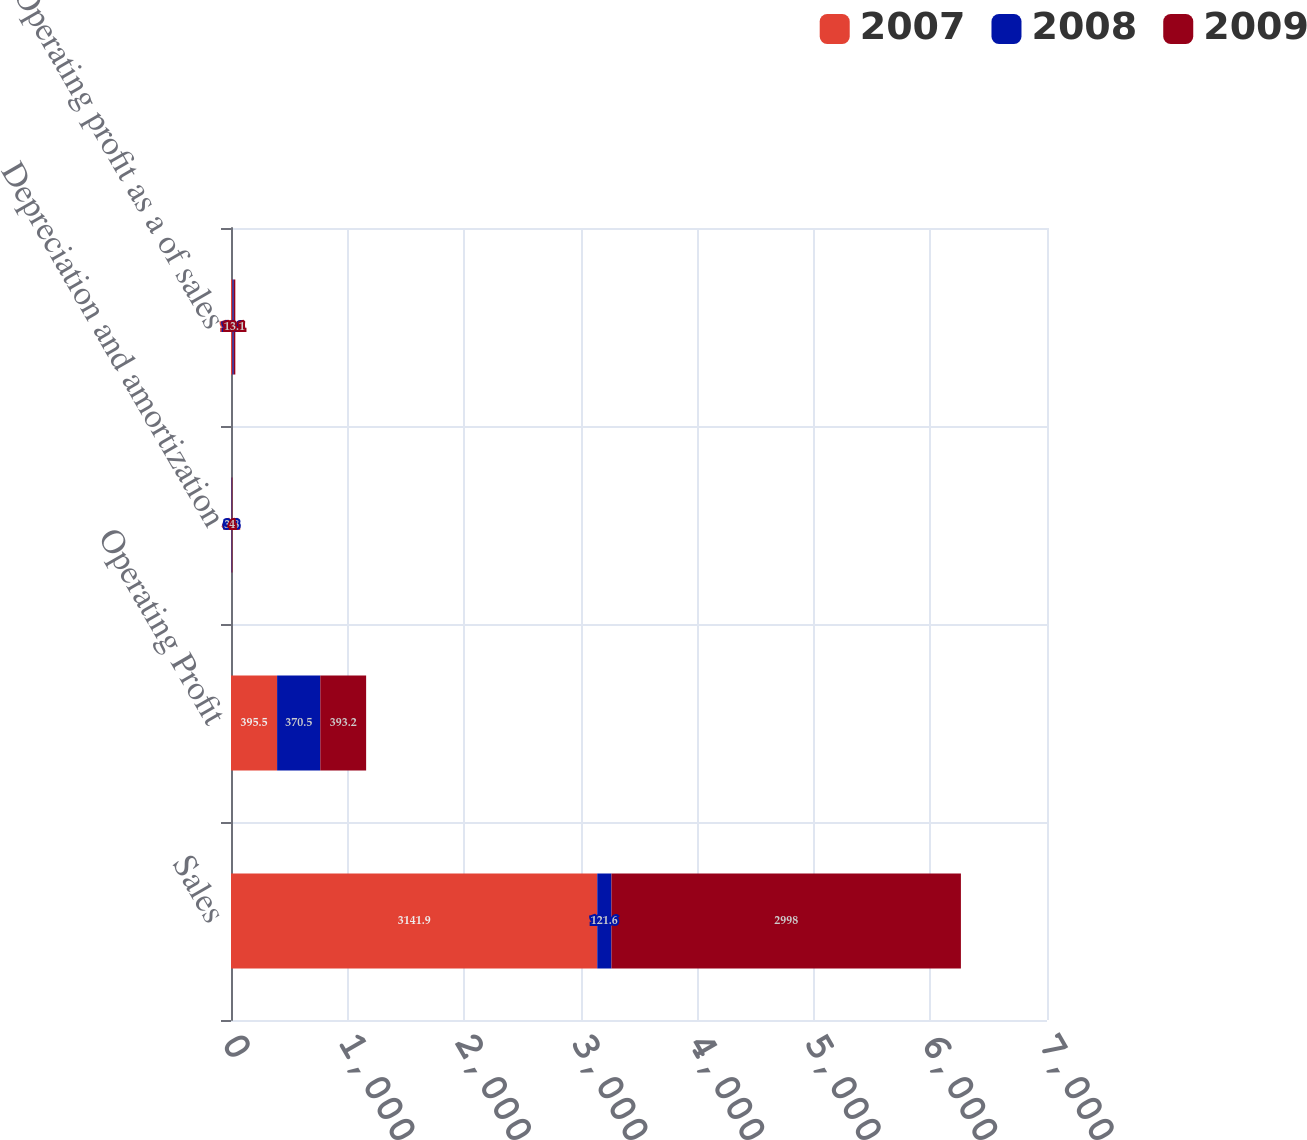Convert chart to OTSL. <chart><loc_0><loc_0><loc_500><loc_500><stacked_bar_chart><ecel><fcel>Sales<fcel>Operating Profit<fcel>Depreciation and amortization<fcel>Operating profit as a of sales<nl><fcel>2007<fcel>3141.9<fcel>395.5<fcel>4.1<fcel>12.6<nl><fcel>2008<fcel>121.6<fcel>370.5<fcel>3.8<fcel>11.3<nl><fcel>2009<fcel>2998<fcel>393.2<fcel>4<fcel>13.1<nl></chart> 